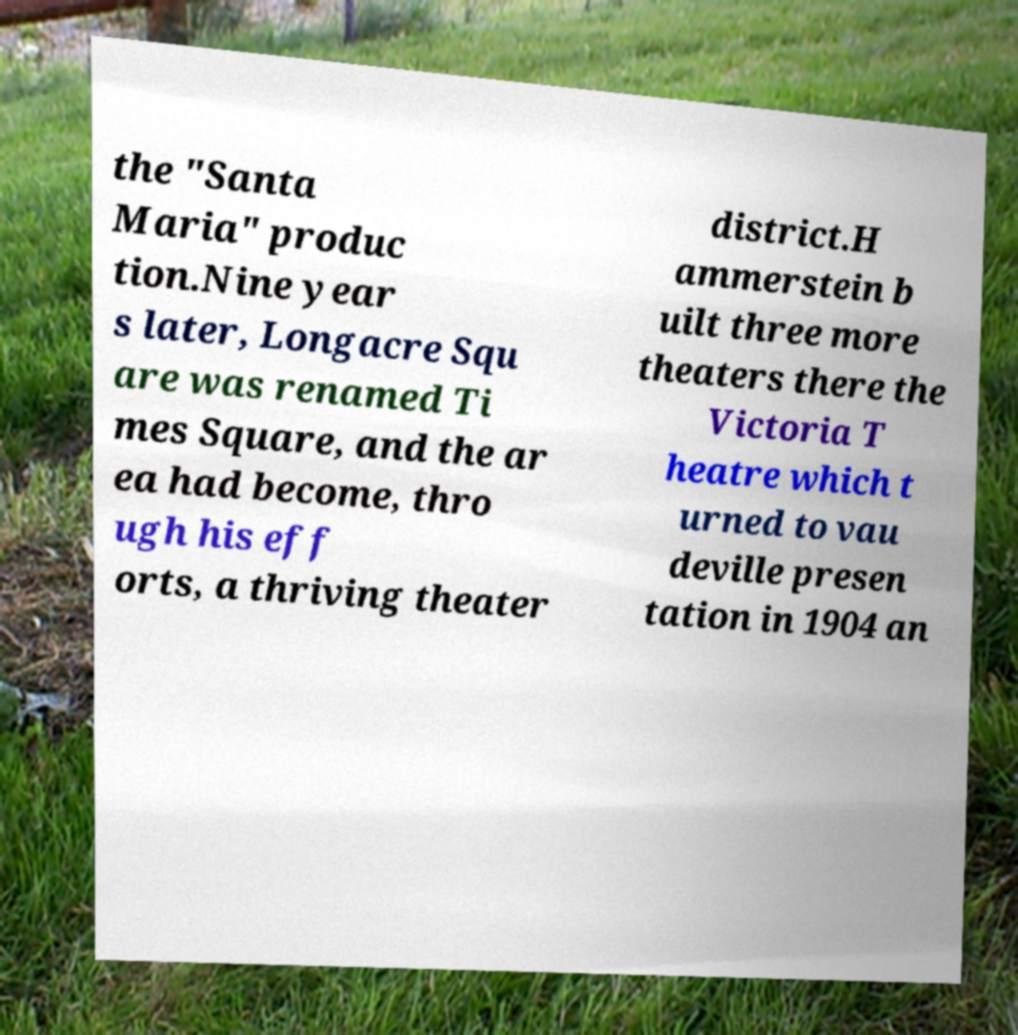There's text embedded in this image that I need extracted. Can you transcribe it verbatim? the "Santa Maria" produc tion.Nine year s later, Longacre Squ are was renamed Ti mes Square, and the ar ea had become, thro ugh his eff orts, a thriving theater district.H ammerstein b uilt three more theaters there the Victoria T heatre which t urned to vau deville presen tation in 1904 an 